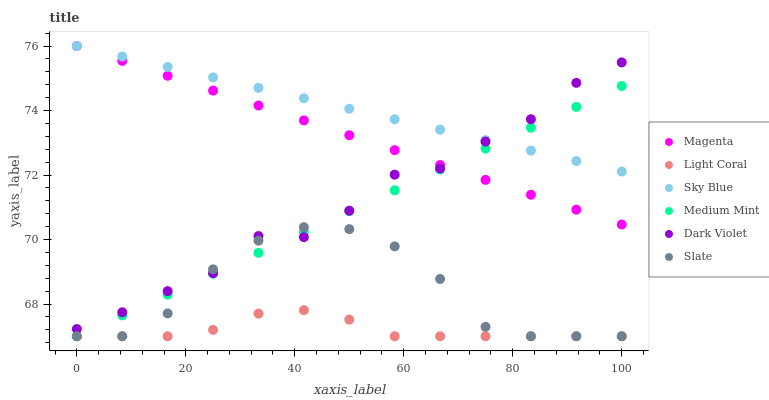Does Light Coral have the minimum area under the curve?
Answer yes or no. Yes. Does Sky Blue have the maximum area under the curve?
Answer yes or no. Yes. Does Slate have the minimum area under the curve?
Answer yes or no. No. Does Slate have the maximum area under the curve?
Answer yes or no. No. Is Magenta the smoothest?
Answer yes or no. Yes. Is Dark Violet the roughest?
Answer yes or no. Yes. Is Slate the smoothest?
Answer yes or no. No. Is Slate the roughest?
Answer yes or no. No. Does Medium Mint have the lowest value?
Answer yes or no. Yes. Does Dark Violet have the lowest value?
Answer yes or no. No. Does Magenta have the highest value?
Answer yes or no. Yes. Does Slate have the highest value?
Answer yes or no. No. Is Light Coral less than Sky Blue?
Answer yes or no. Yes. Is Sky Blue greater than Light Coral?
Answer yes or no. Yes. Does Light Coral intersect Slate?
Answer yes or no. Yes. Is Light Coral less than Slate?
Answer yes or no. No. Is Light Coral greater than Slate?
Answer yes or no. No. Does Light Coral intersect Sky Blue?
Answer yes or no. No. 